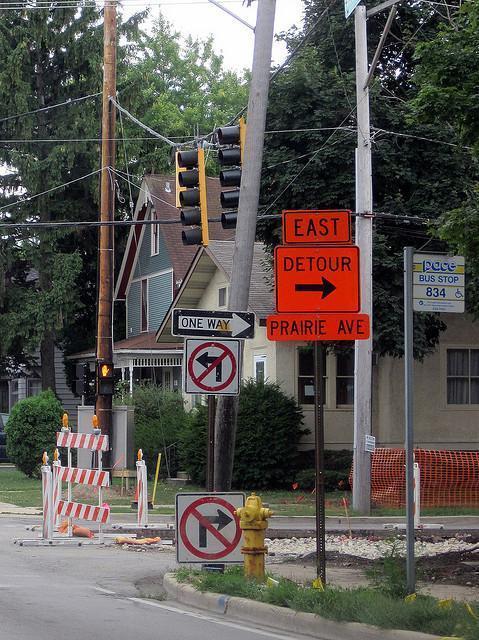How many directions can you turn at this traffic light?
Give a very brief answer. 1. 